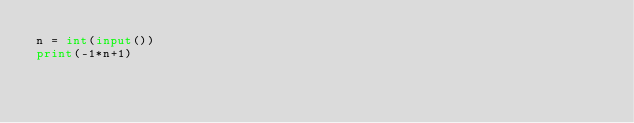<code> <loc_0><loc_0><loc_500><loc_500><_Python_>n = int(input())
print(-1*n+1)</code> 